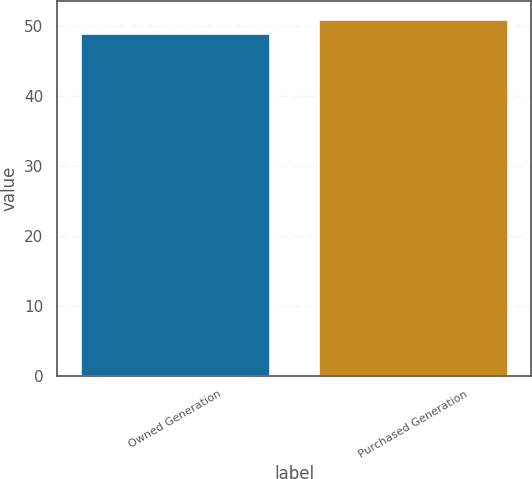Convert chart to OTSL. <chart><loc_0><loc_0><loc_500><loc_500><bar_chart><fcel>Owned Generation<fcel>Purchased Generation<nl><fcel>49<fcel>51<nl></chart> 